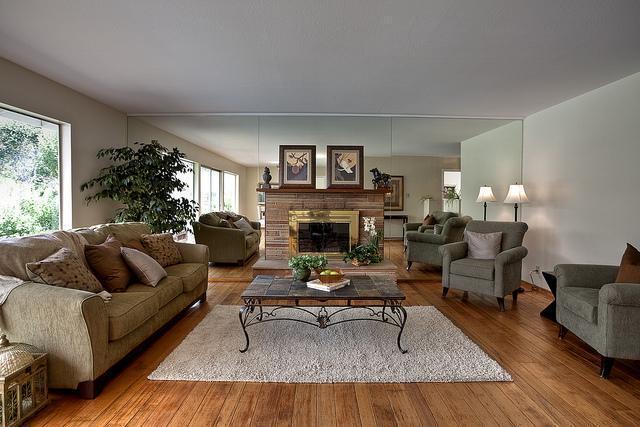How many places to sit are in the image?
Give a very brief answer. 5. How many chairs are in the photo?
Give a very brief answer. 2. How many couches are visible?
Give a very brief answer. 2. 